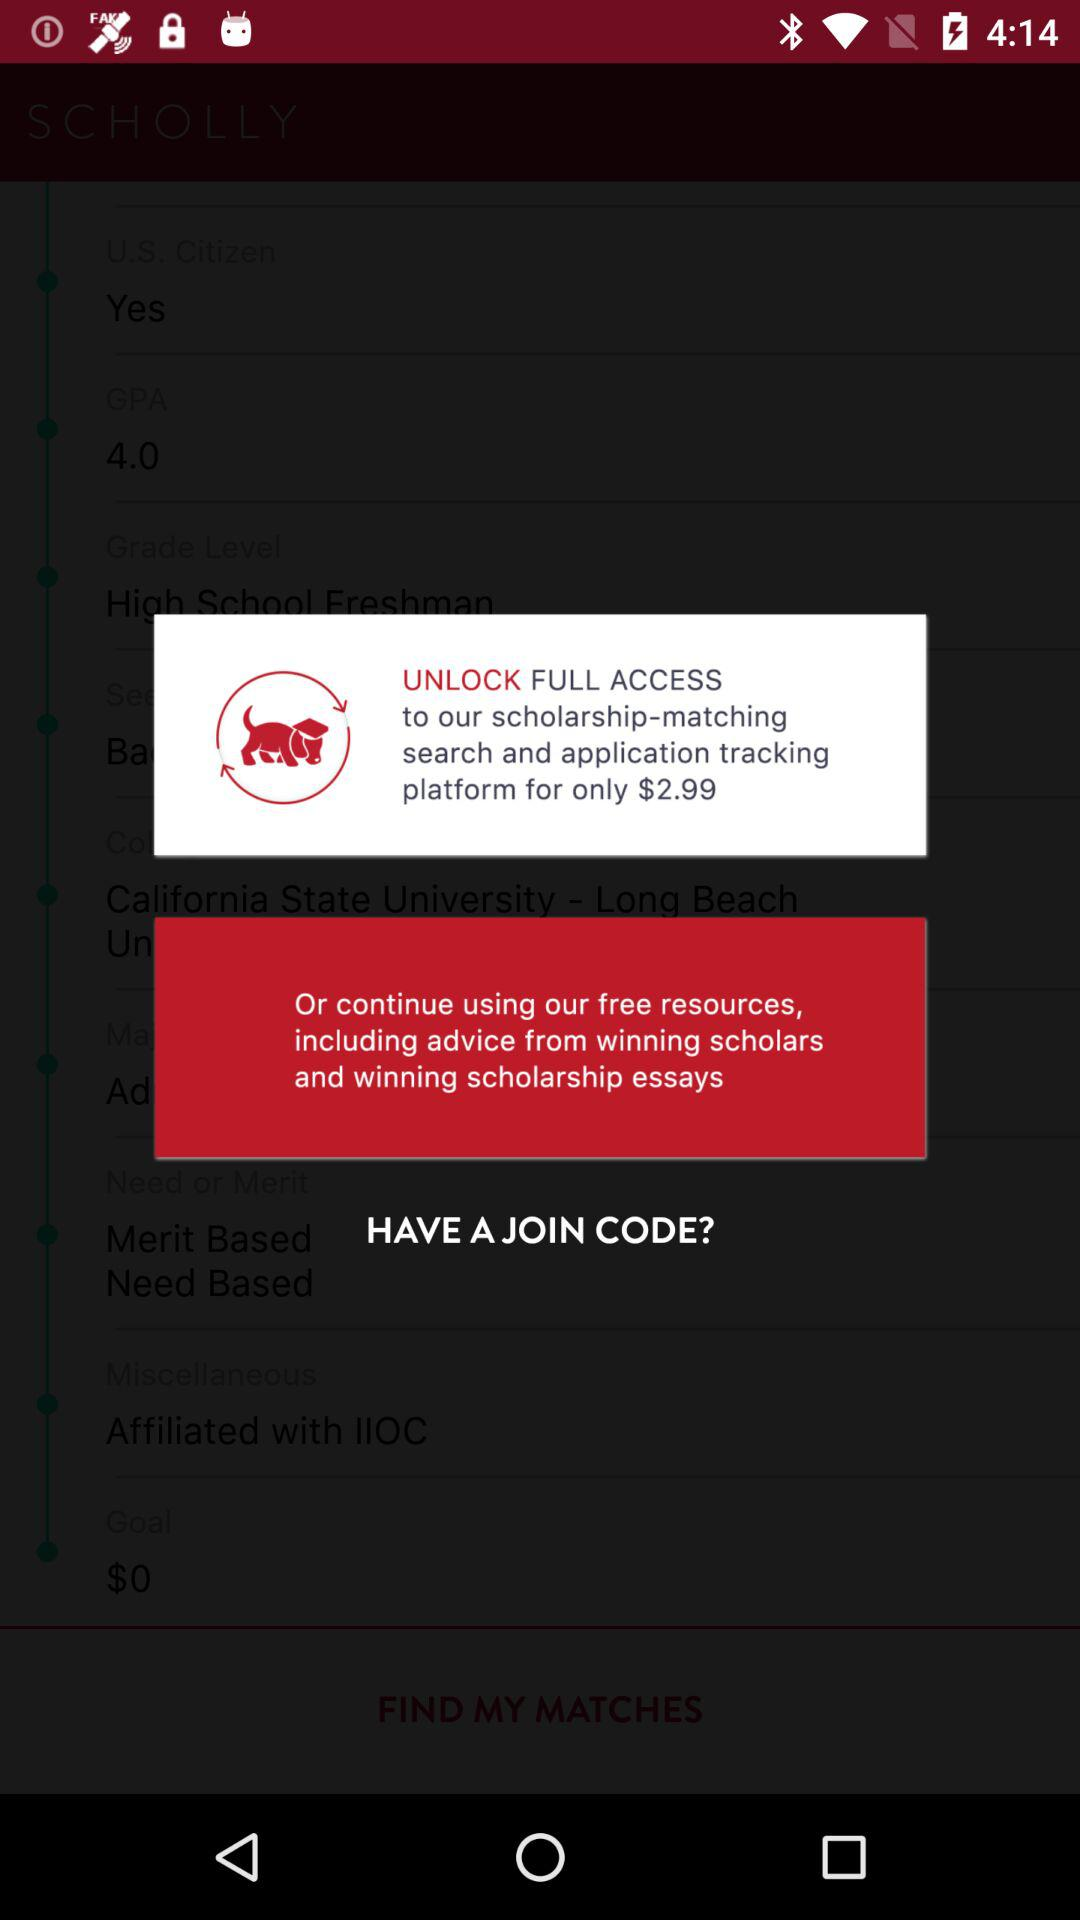How much more is the cost of full access to the platform than the cost of the free resources?
Answer the question using a single word or phrase. $2.99 